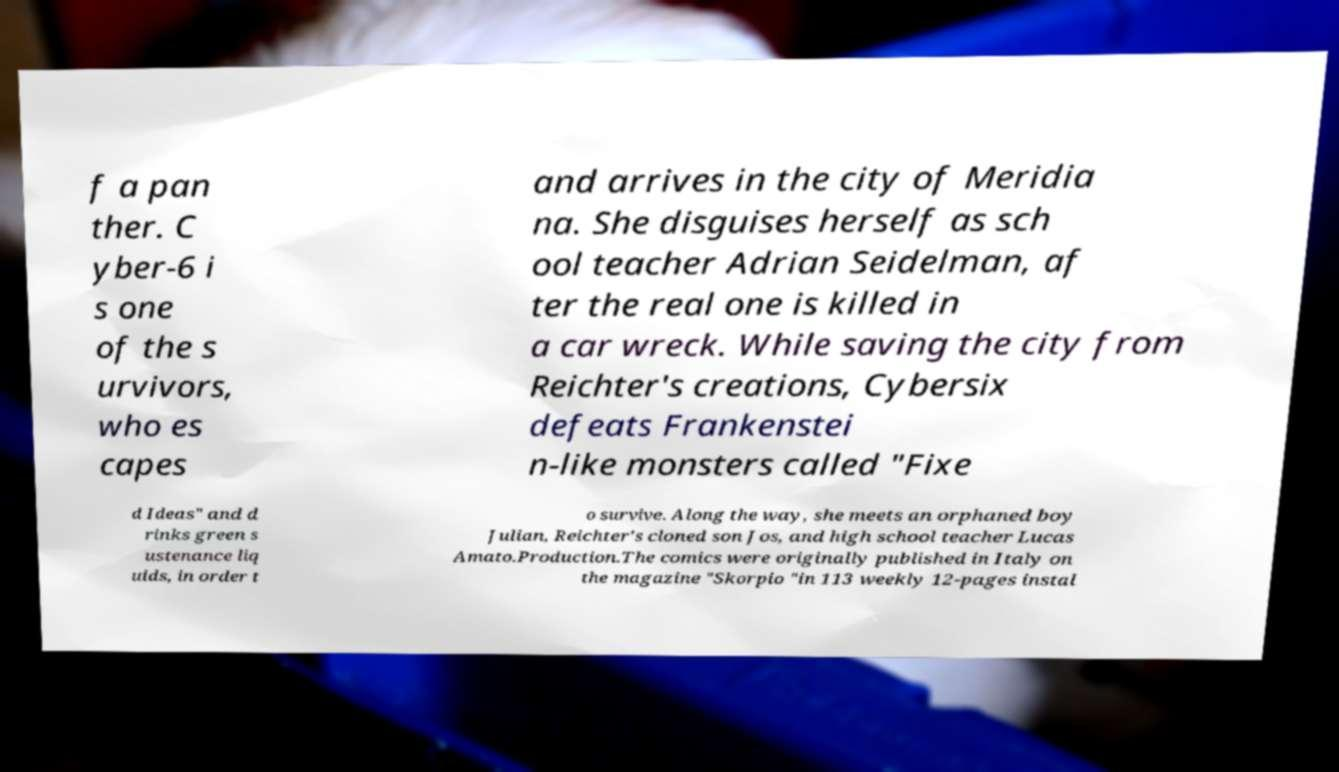Can you accurately transcribe the text from the provided image for me? f a pan ther. C yber-6 i s one of the s urvivors, who es capes and arrives in the city of Meridia na. She disguises herself as sch ool teacher Adrian Seidelman, af ter the real one is killed in a car wreck. While saving the city from Reichter's creations, Cybersix defeats Frankenstei n-like monsters called "Fixe d Ideas" and d rinks green s ustenance liq uids, in order t o survive. Along the way, she meets an orphaned boy Julian, Reichter's cloned son Jos, and high school teacher Lucas Amato.Production.The comics were originally published in Italy on the magazine "Skorpio "in 113 weekly 12-pages instal 